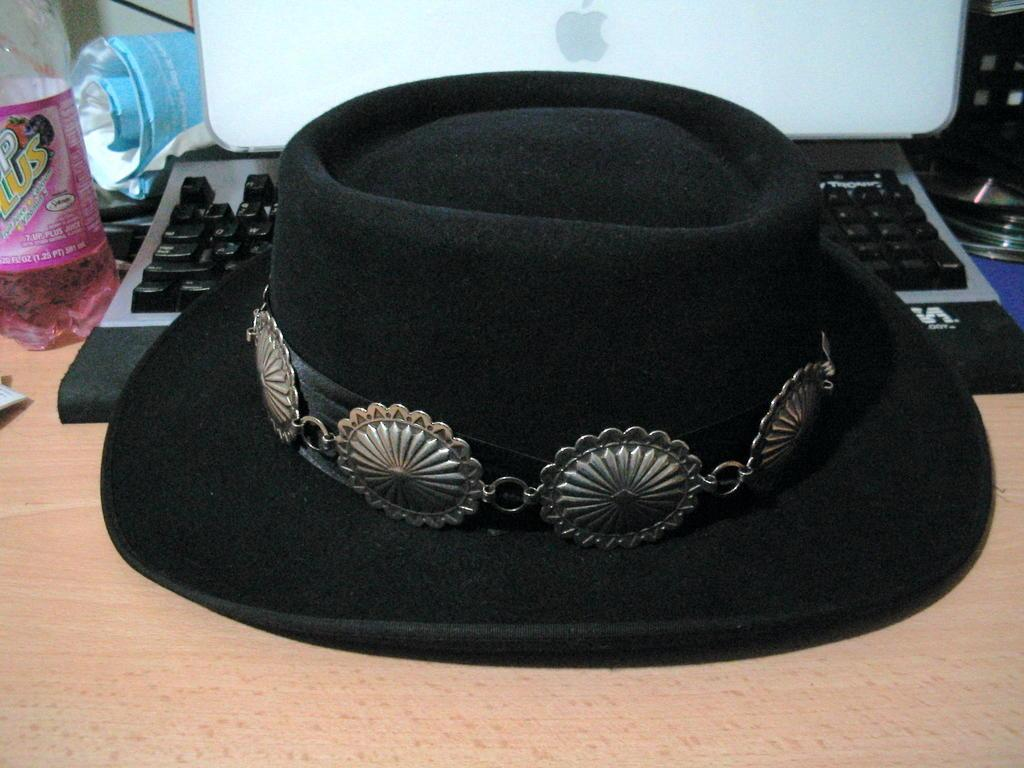What type of hat is in the image? There is a black hat in the image. Where is the black hat placed? The black hat is placed on a keyboard. What else can be seen behind the black hat and keyboard? There are other objects visible behind the black hat and keyboard. How does the bridge connect to the twig in the image? There is no bridge or twig present in the image. 